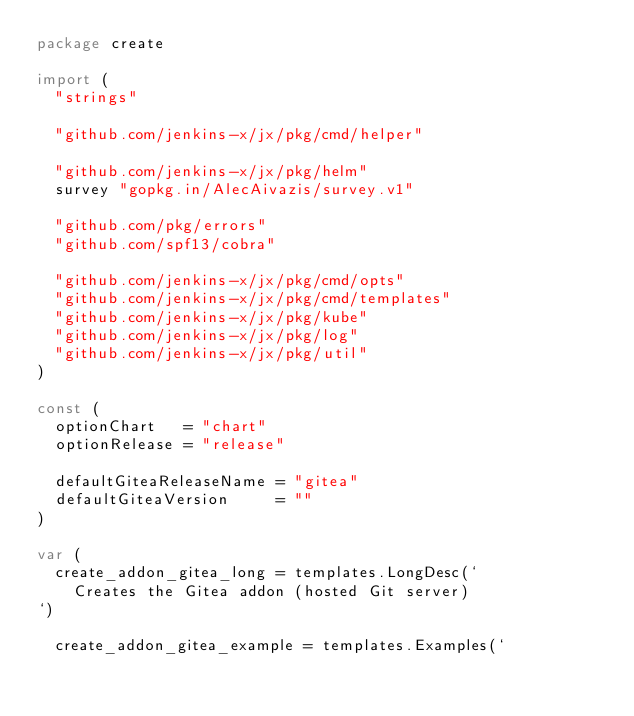<code> <loc_0><loc_0><loc_500><loc_500><_Go_>package create

import (
	"strings"

	"github.com/jenkins-x/jx/pkg/cmd/helper"

	"github.com/jenkins-x/jx/pkg/helm"
	survey "gopkg.in/AlecAivazis/survey.v1"

	"github.com/pkg/errors"
	"github.com/spf13/cobra"

	"github.com/jenkins-x/jx/pkg/cmd/opts"
	"github.com/jenkins-x/jx/pkg/cmd/templates"
	"github.com/jenkins-x/jx/pkg/kube"
	"github.com/jenkins-x/jx/pkg/log"
	"github.com/jenkins-x/jx/pkg/util"
)

const (
	optionChart   = "chart"
	optionRelease = "release"

	defaultGiteaReleaseName = "gitea"
	defaultGiteaVersion     = ""
)

var (
	create_addon_gitea_long = templates.LongDesc(`
		Creates the Gitea addon (hosted Git server)
`)

	create_addon_gitea_example = templates.Examples(`</code> 